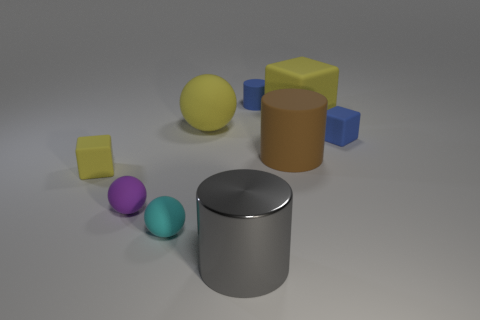Add 1 cylinders. How many objects exist? 10 Subtract all blocks. How many objects are left? 6 Add 1 small purple spheres. How many small purple spheres are left? 2 Add 5 yellow objects. How many yellow objects exist? 8 Subtract 0 red balls. How many objects are left? 9 Subtract all small cyan spheres. Subtract all tiny blue cubes. How many objects are left? 7 